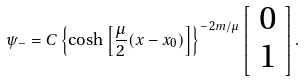<formula> <loc_0><loc_0><loc_500><loc_500>\psi _ { - } = C \left \{ \cosh \left [ \frac { \mu } { 2 } ( x - x _ { 0 } ) \right ] \right \} ^ { - 2 m / \mu } \left [ \begin{array} { c } 0 \\ 1 \end{array} \right ] .</formula> 